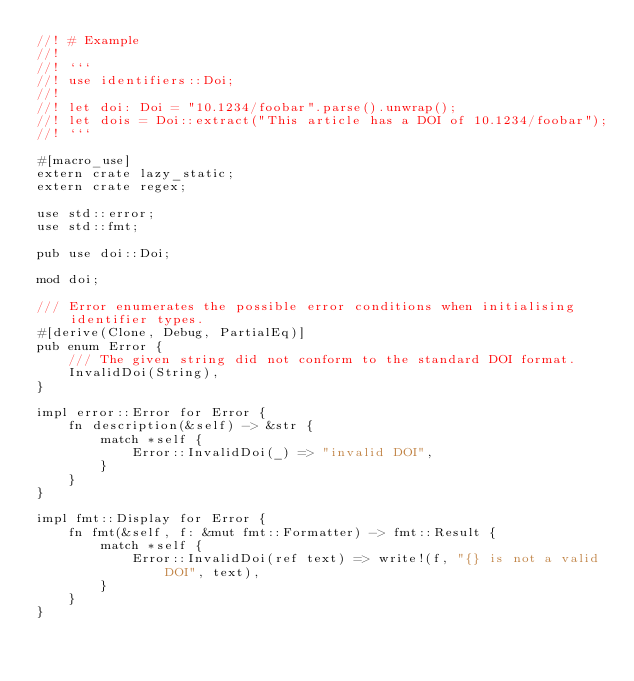<code> <loc_0><loc_0><loc_500><loc_500><_Rust_>//! # Example
//!
//! ```
//! use identifiers::Doi;
//!
//! let doi: Doi = "10.1234/foobar".parse().unwrap();
//! let dois = Doi::extract("This article has a DOI of 10.1234/foobar");
//! ```

#[macro_use]
extern crate lazy_static;
extern crate regex;

use std::error;
use std::fmt;

pub use doi::Doi;

mod doi;

/// Error enumerates the possible error conditions when initialising identifier types.
#[derive(Clone, Debug, PartialEq)]
pub enum Error {
    /// The given string did not conform to the standard DOI format.
    InvalidDoi(String),
}

impl error::Error for Error {
    fn description(&self) -> &str {
        match *self {
            Error::InvalidDoi(_) => "invalid DOI",
        }
    }
}

impl fmt::Display for Error {
    fn fmt(&self, f: &mut fmt::Formatter) -> fmt::Result {
        match *self {
            Error::InvalidDoi(ref text) => write!(f, "{} is not a valid DOI", text),
        }
    }
}
</code> 